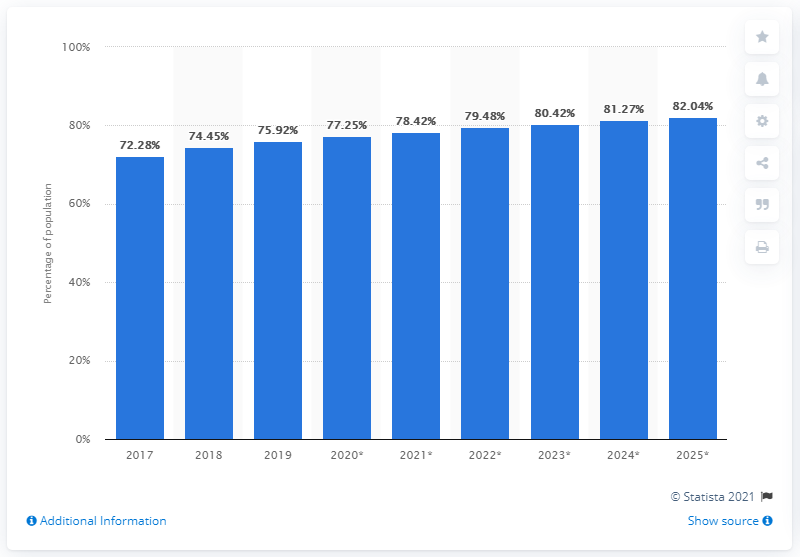Mention a couple of crucial points in this snapshot. By 2025, it is projected that mobile internet penetration in Israel will increase by 82.04%. In 2019, 75.92% of Israel's population accessed the internet from their mobile device. 